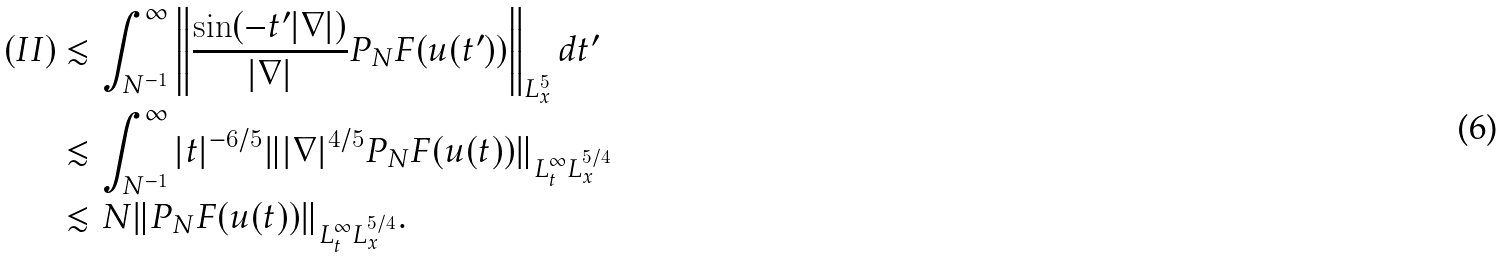Convert formula to latex. <formula><loc_0><loc_0><loc_500><loc_500>( I I ) & \lesssim \int _ { N ^ { - 1 } } ^ { \infty } \left \| \frac { \sin ( - t ^ { \prime } | \nabla | ) } { | \nabla | } P _ { N } F ( u ( t ^ { \prime } ) ) \right \| _ { L _ { x } ^ { 5 } } d t ^ { \prime } \\ & \lesssim \int _ { N ^ { - 1 } } ^ { \infty } | t | ^ { - 6 / 5 } \| | \nabla | ^ { 4 / 5 } P _ { N } F ( u ( t ) ) \| _ { L _ { t } ^ { \infty } L _ { x } ^ { 5 / 4 } } \\ & \lesssim N \| P _ { N } F ( u ( t ) ) \| _ { L _ { t } ^ { \infty } L _ { x } ^ { 5 / 4 } } .</formula> 